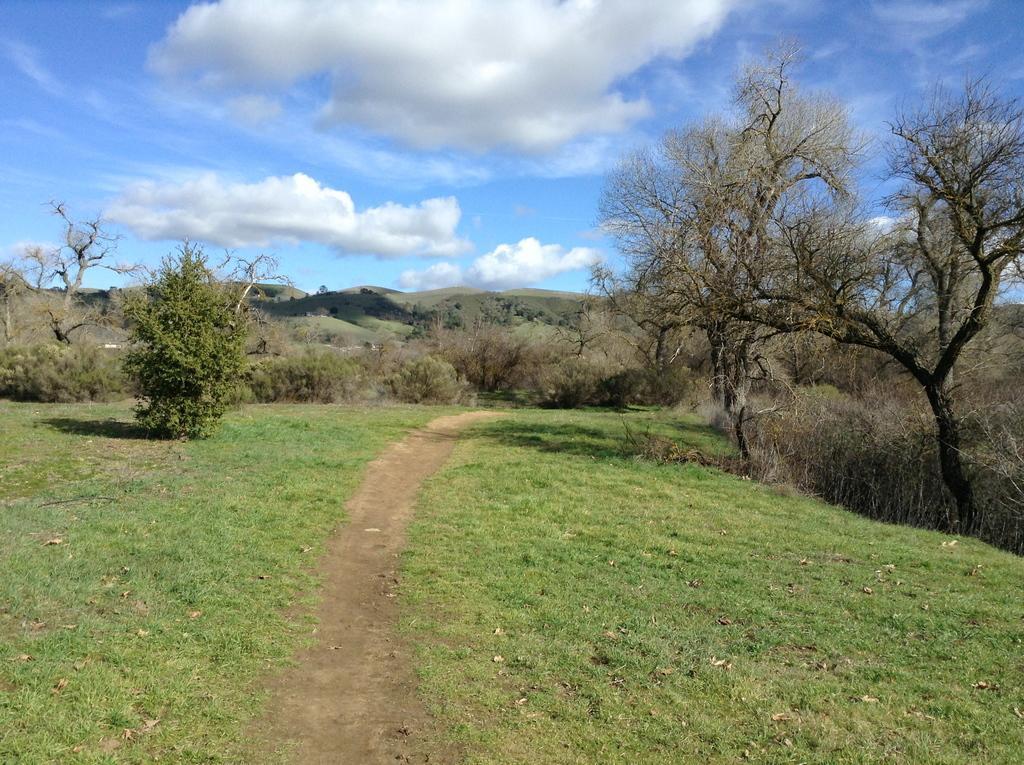Could you give a brief overview of what you see in this image? In this picture we can see the grass, path, trees, mountains and in the background we can see the sky with clouds. 